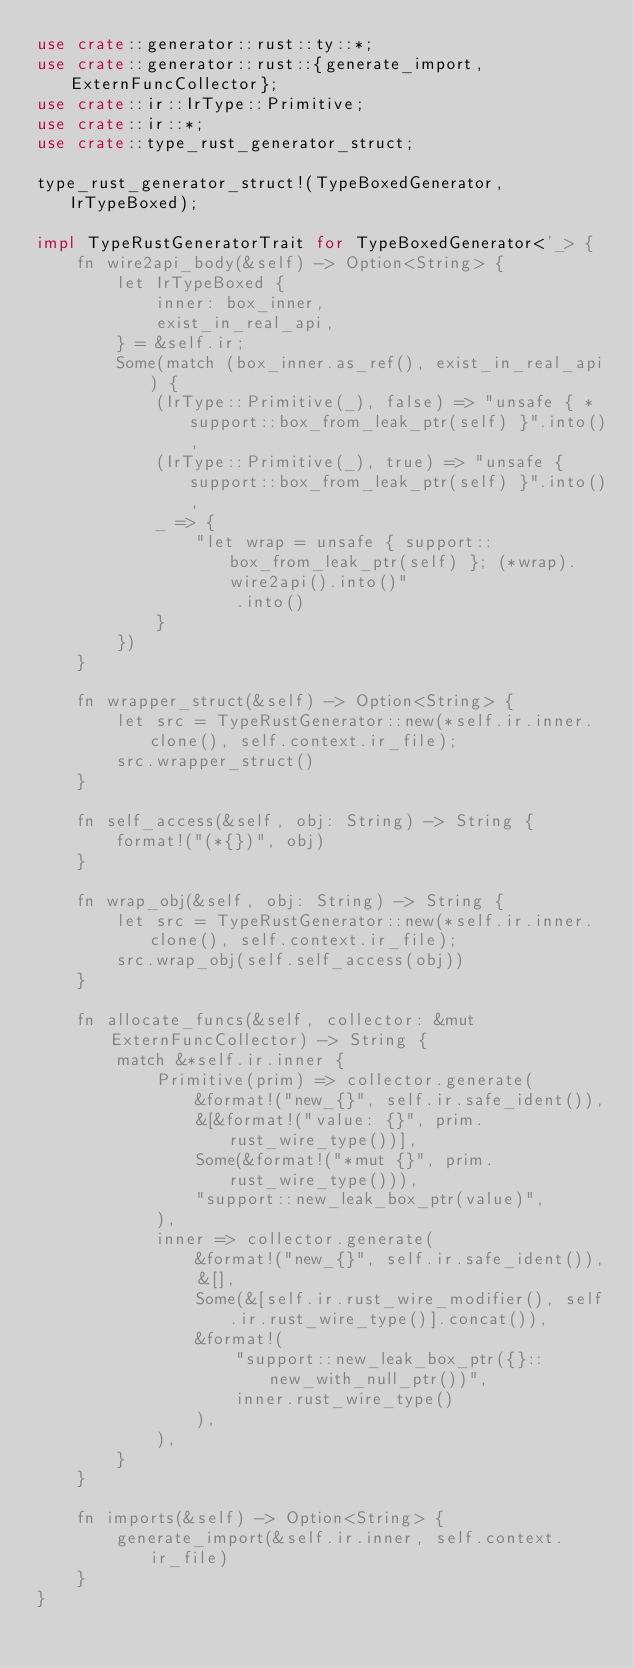<code> <loc_0><loc_0><loc_500><loc_500><_Rust_>use crate::generator::rust::ty::*;
use crate::generator::rust::{generate_import, ExternFuncCollector};
use crate::ir::IrType::Primitive;
use crate::ir::*;
use crate::type_rust_generator_struct;

type_rust_generator_struct!(TypeBoxedGenerator, IrTypeBoxed);

impl TypeRustGeneratorTrait for TypeBoxedGenerator<'_> {
    fn wire2api_body(&self) -> Option<String> {
        let IrTypeBoxed {
            inner: box_inner,
            exist_in_real_api,
        } = &self.ir;
        Some(match (box_inner.as_ref(), exist_in_real_api) {
            (IrType::Primitive(_), false) => "unsafe { *support::box_from_leak_ptr(self) }".into(),
            (IrType::Primitive(_), true) => "unsafe { support::box_from_leak_ptr(self) }".into(),
            _ => {
                "let wrap = unsafe { support::box_from_leak_ptr(self) }; (*wrap).wire2api().into()"
                    .into()
            }
        })
    }

    fn wrapper_struct(&self) -> Option<String> {
        let src = TypeRustGenerator::new(*self.ir.inner.clone(), self.context.ir_file);
        src.wrapper_struct()
    }

    fn self_access(&self, obj: String) -> String {
        format!("(*{})", obj)
    }

    fn wrap_obj(&self, obj: String) -> String {
        let src = TypeRustGenerator::new(*self.ir.inner.clone(), self.context.ir_file);
        src.wrap_obj(self.self_access(obj))
    }

    fn allocate_funcs(&self, collector: &mut ExternFuncCollector) -> String {
        match &*self.ir.inner {
            Primitive(prim) => collector.generate(
                &format!("new_{}", self.ir.safe_ident()),
                &[&format!("value: {}", prim.rust_wire_type())],
                Some(&format!("*mut {}", prim.rust_wire_type())),
                "support::new_leak_box_ptr(value)",
            ),
            inner => collector.generate(
                &format!("new_{}", self.ir.safe_ident()),
                &[],
                Some(&[self.ir.rust_wire_modifier(), self.ir.rust_wire_type()].concat()),
                &format!(
                    "support::new_leak_box_ptr({}::new_with_null_ptr())",
                    inner.rust_wire_type()
                ),
            ),
        }
    }

    fn imports(&self) -> Option<String> {
        generate_import(&self.ir.inner, self.context.ir_file)
    }
}
</code> 